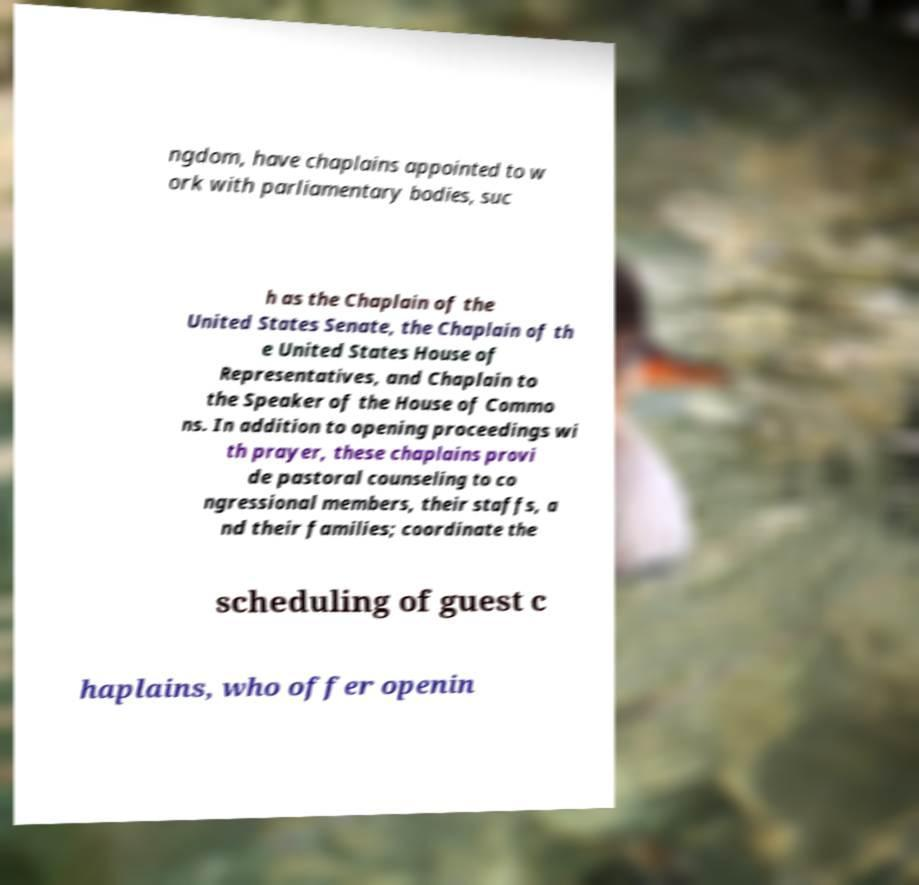For documentation purposes, I need the text within this image transcribed. Could you provide that? ngdom, have chaplains appointed to w ork with parliamentary bodies, suc h as the Chaplain of the United States Senate, the Chaplain of th e United States House of Representatives, and Chaplain to the Speaker of the House of Commo ns. In addition to opening proceedings wi th prayer, these chaplains provi de pastoral counseling to co ngressional members, their staffs, a nd their families; coordinate the scheduling of guest c haplains, who offer openin 